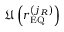<formula> <loc_0><loc_0><loc_500><loc_500>\mathfrak { U } \left ( r _ { E Q } ^ { \left ( j _ { R } \right ) } \right )</formula> 